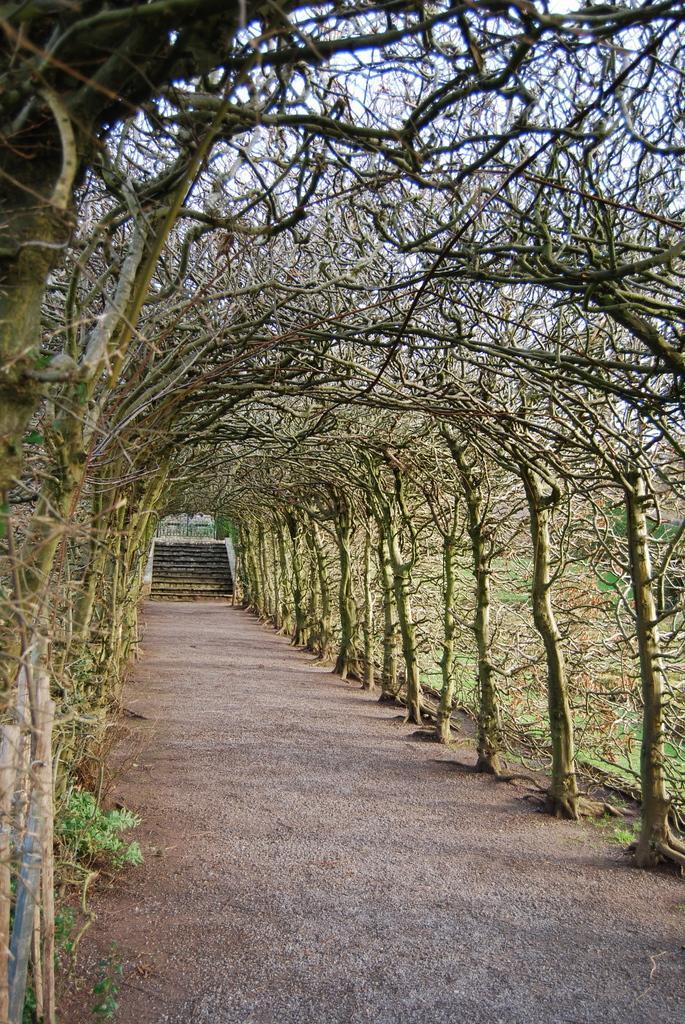In one or two sentences, can you explain what this image depicts? In this image, we can see trees and there are stairs. At the bottom, there is ground. 